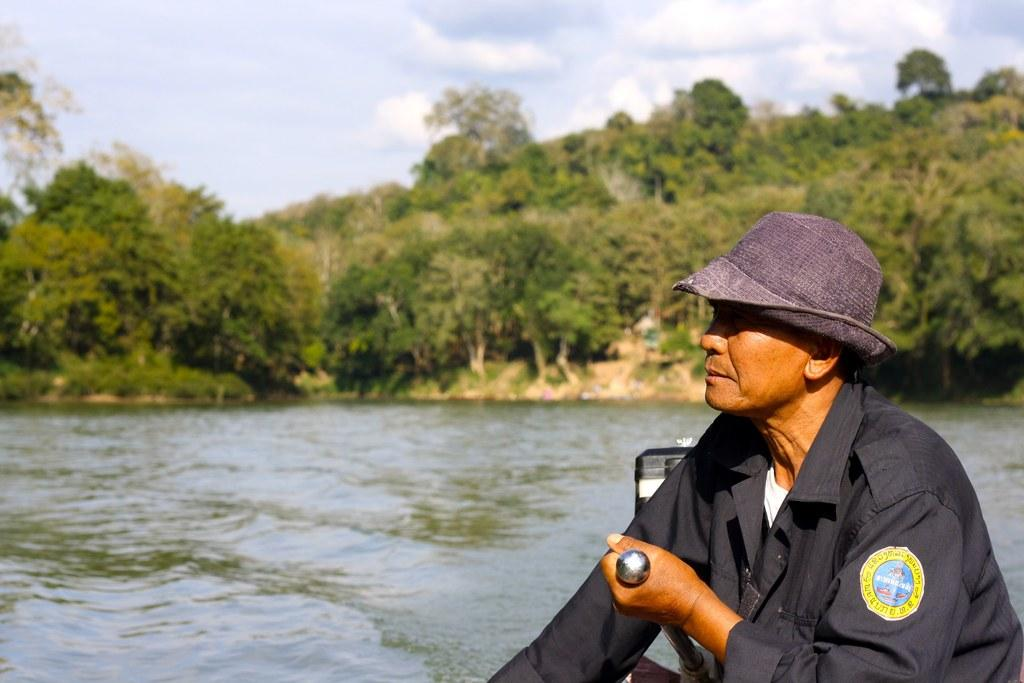What is the person in the image wearing? The person is wearing a black dress. What is the person holding in the image? The person is holding an object. Where is the person located in the image? The person is sitting in a boat. What can be seen in the background of the image? There is water, trees, and the sky visible in the background. How many eggs can be seen in the image? There are no eggs present in the image. What type of feeling does the person in the image seem to be experiencing? The image does not provide any information about the person's feelings or emotions. 